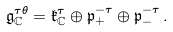<formula> <loc_0><loc_0><loc_500><loc_500>\mathfrak { g } _ { \mathbb { C } } ^ { \tau \theta } = \mathfrak { k } _ { \mathbb { C } } ^ { \tau } \oplus \mathfrak { p } _ { + } ^ { - \tau } \oplus \mathfrak { p } _ { - } ^ { - \tau } \, .</formula> 